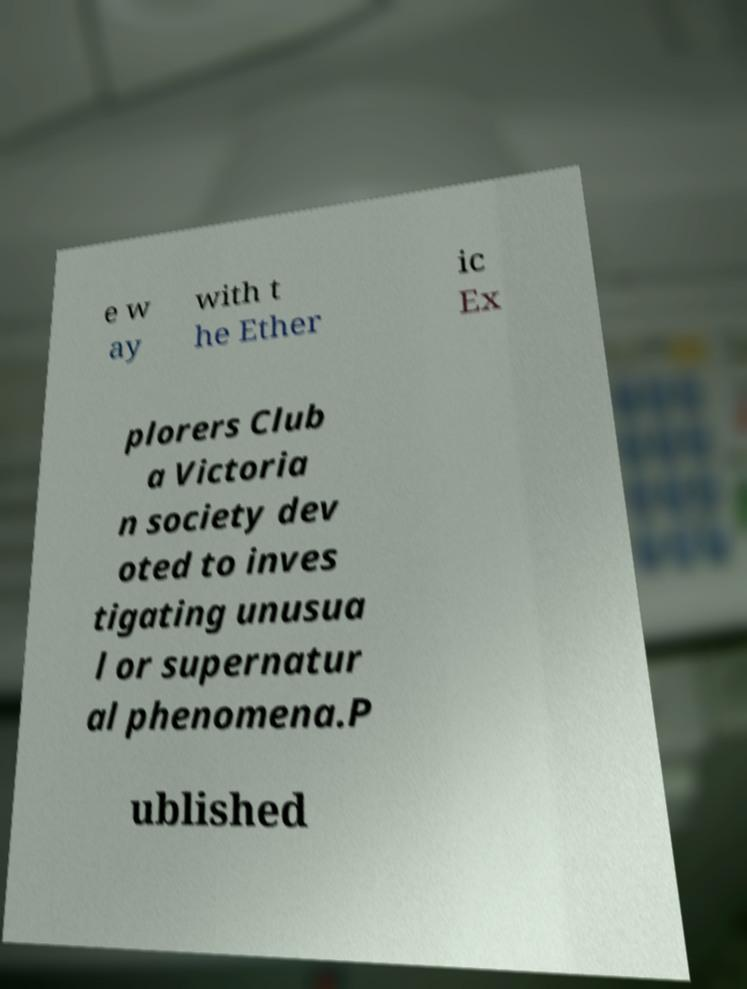For documentation purposes, I need the text within this image transcribed. Could you provide that? e w ay with t he Ether ic Ex plorers Club a Victoria n society dev oted to inves tigating unusua l or supernatur al phenomena.P ublished 